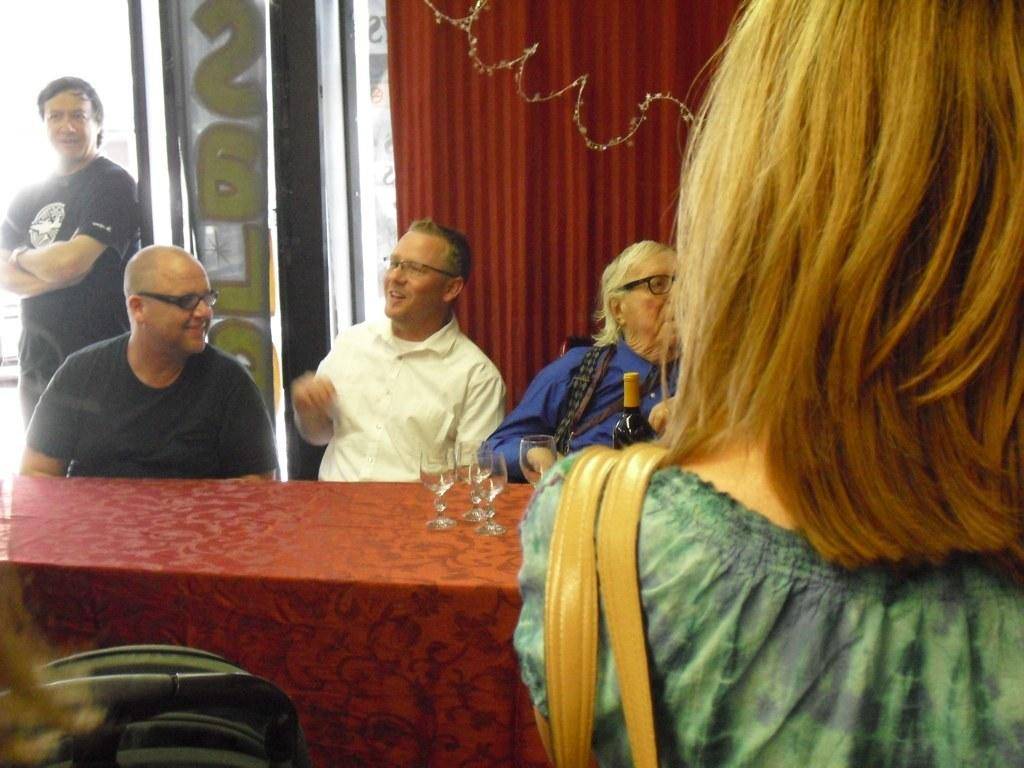How many people are in the image? There are people in the image, but the exact number is not specified. Can you describe the positions of the people in the image? A man is standing among the people, while other people are sitting. Are there any people wearing glasses in the image? Yes, some people in the image are wearing glasses. What is present on the table in the image? There is a table in the image with glasses and a bottle on it. What type of desk can be seen in the image? There is no desk present in the image. 